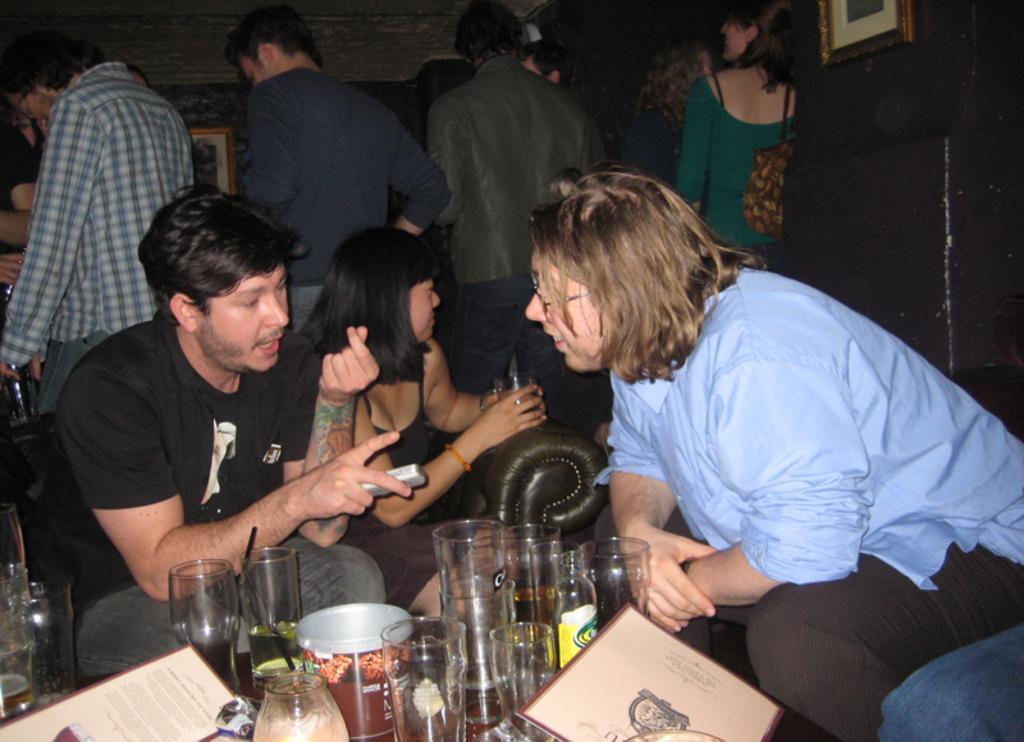Describe this image in one or two sentences. In this image, there are a few people. Among them, some people are sitting. We can also see some objects like glasses and posters at the bottom. We can see the wall with some frames. 